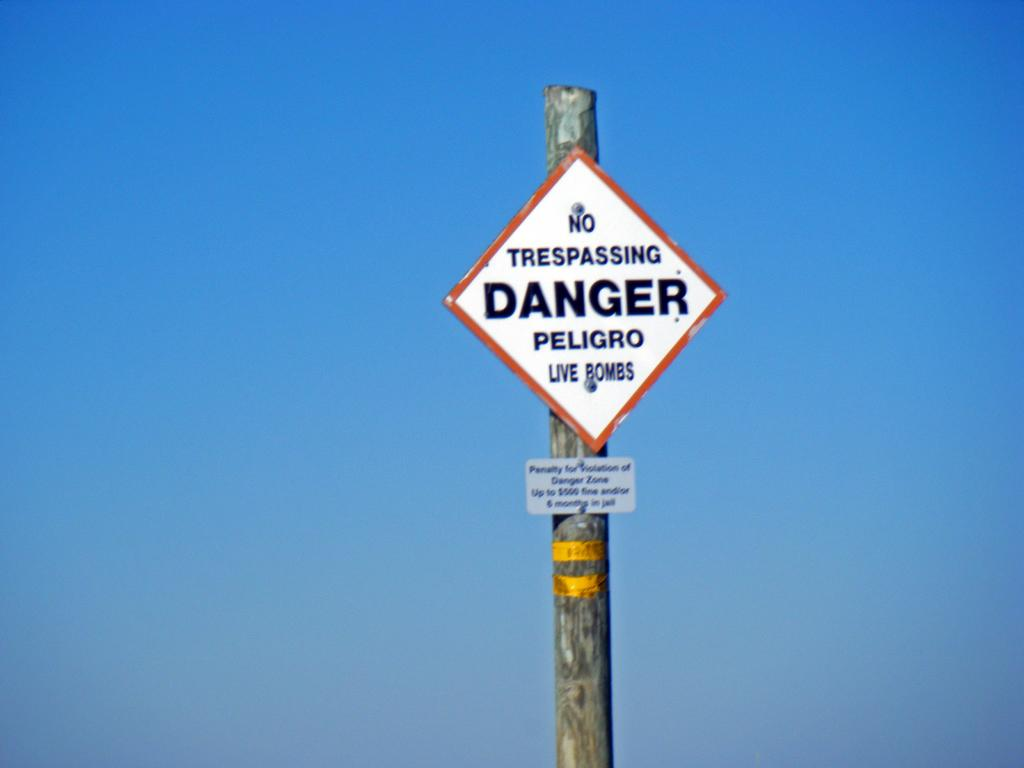<image>
Share a concise interpretation of the image provided. A sign warns of live bombs and says no trespassing. 